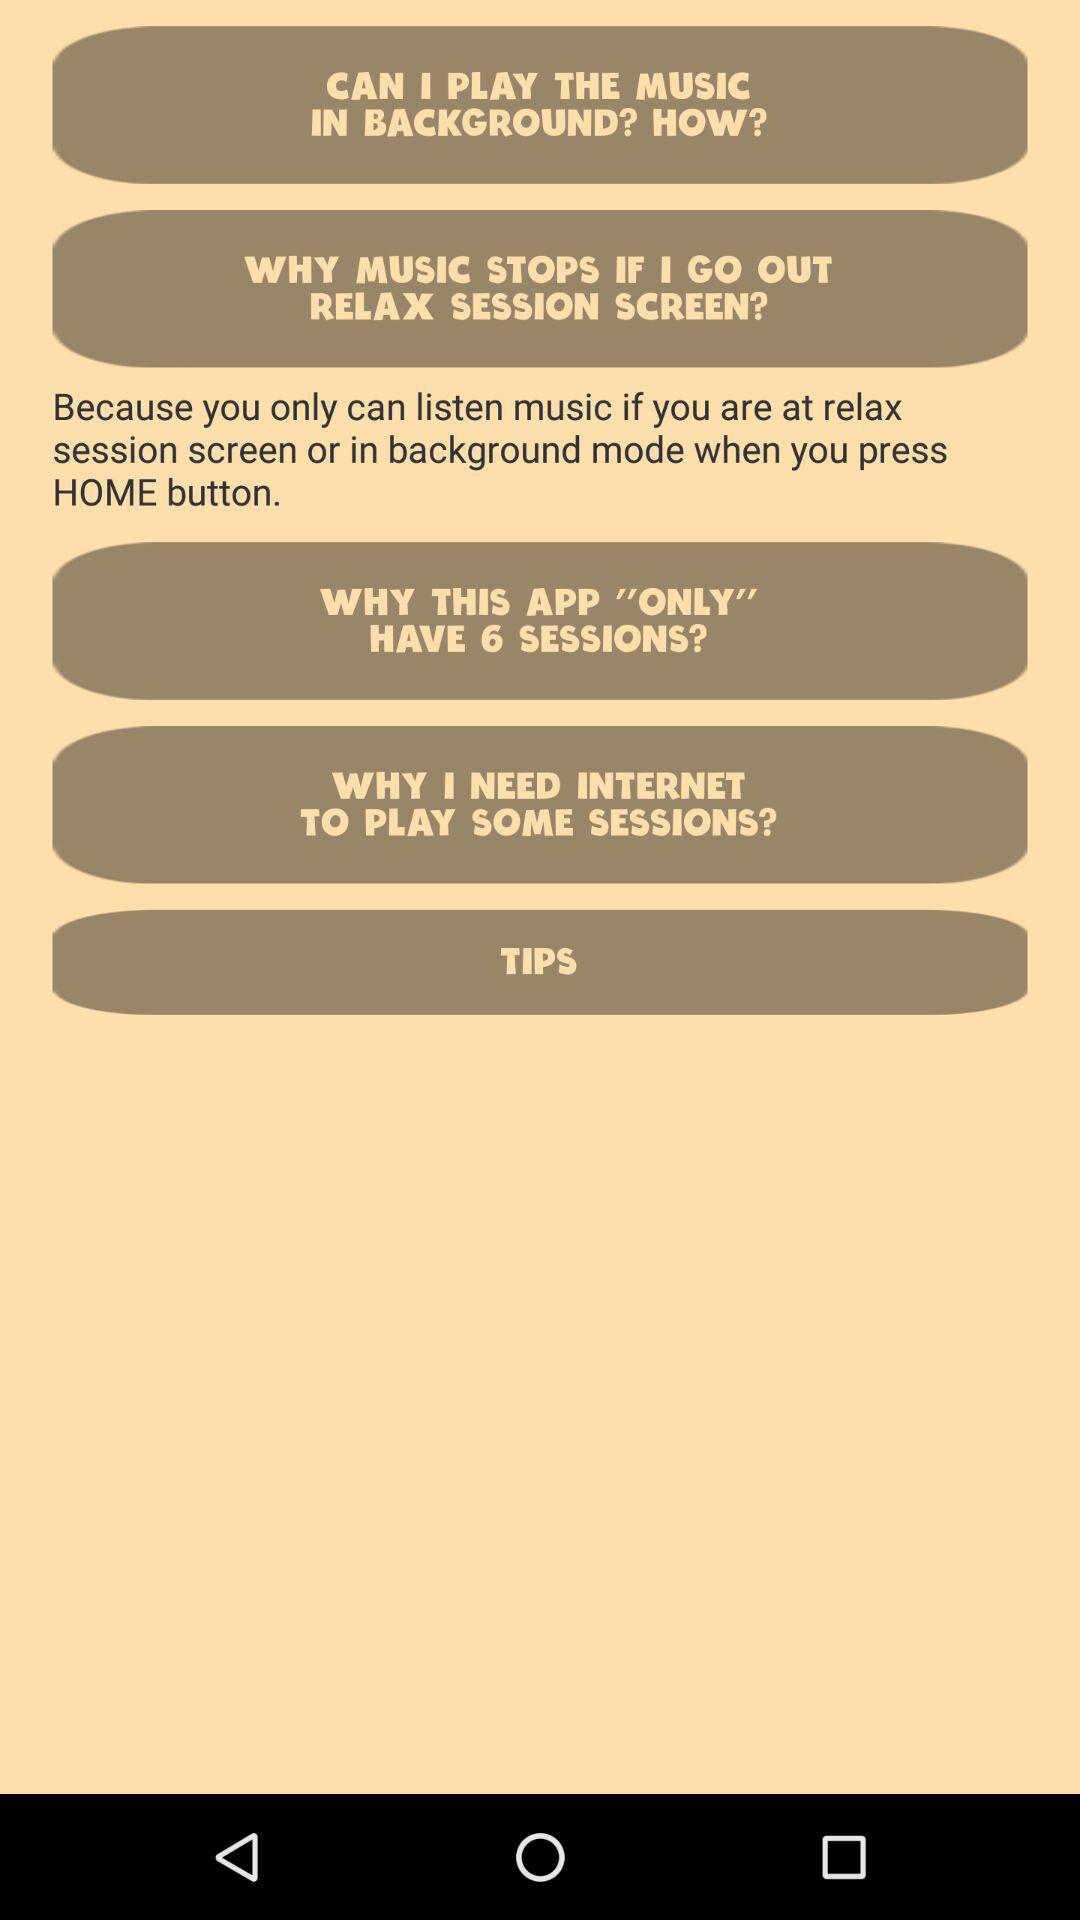In what mode can music be played? The music can be played in background mode. 